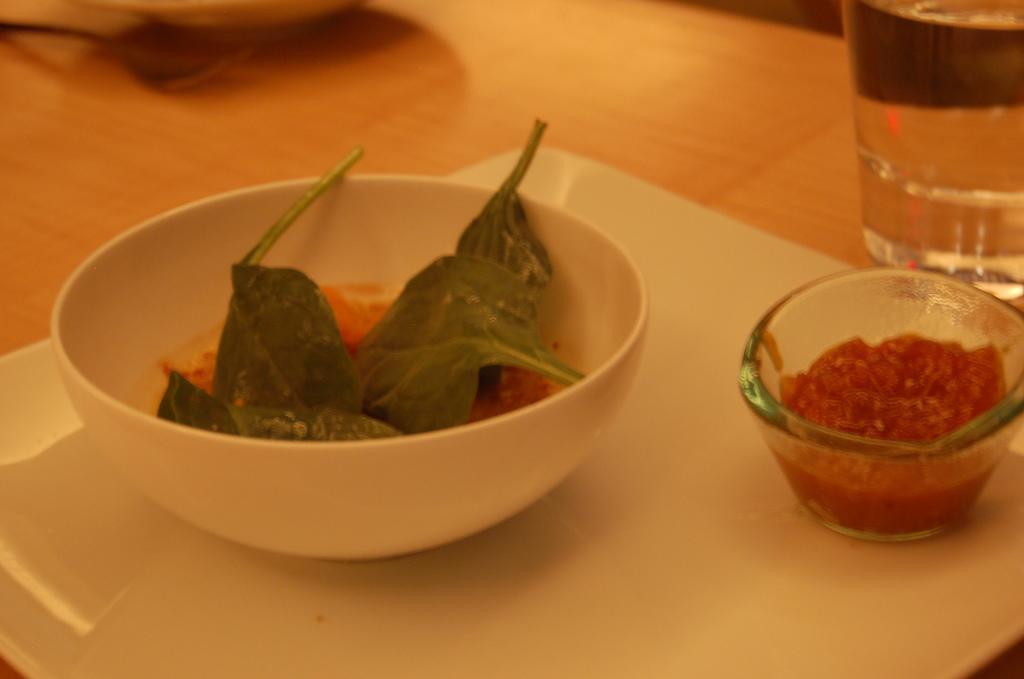Can you describe this image briefly? In the foreground of this picture, there is a platter on which a bowl with few leafs and a bowl with red color paste in it. In the background, there is a glass on the table. 